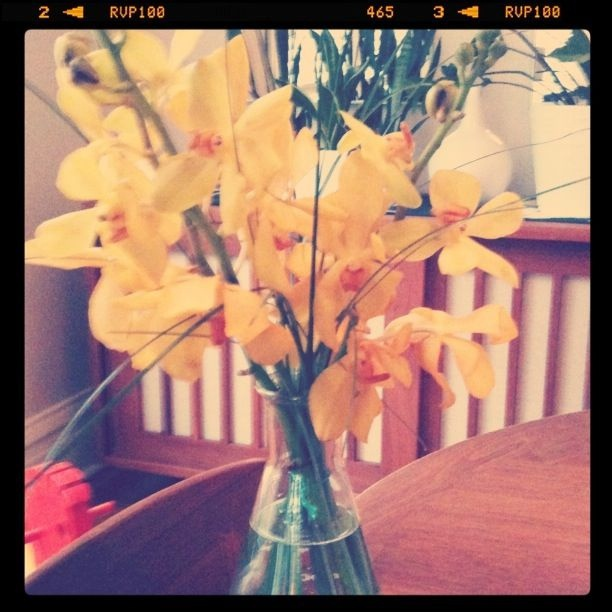Describe the objects in this image and their specific colors. I can see dining table in black and salmon tones, chair in black, purple, navy, and brown tones, and vase in black, gray, blue, darkgray, and lightpink tones in this image. 